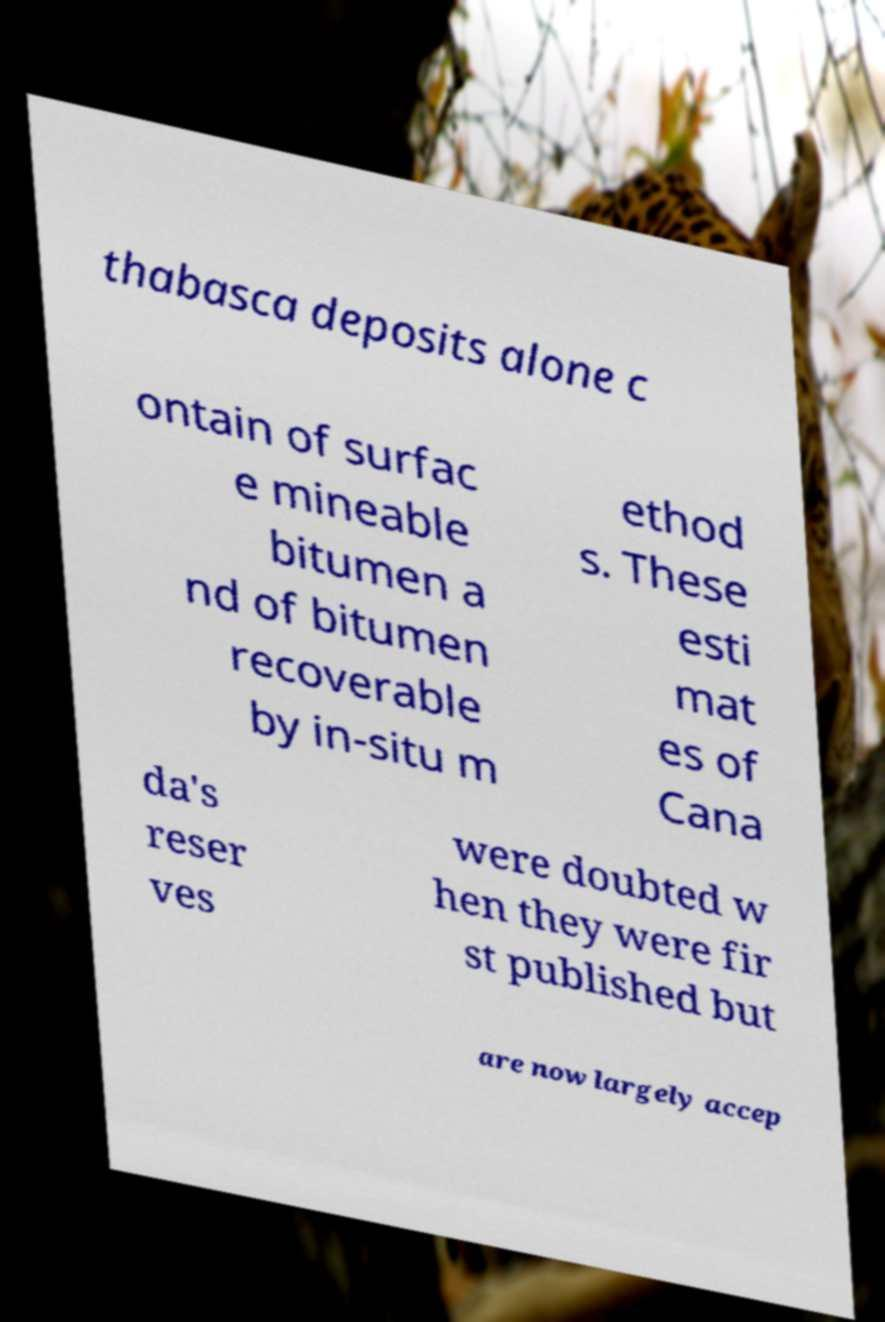Please read and relay the text visible in this image. What does it say? thabasca deposits alone c ontain of surfac e mineable bitumen a nd of bitumen recoverable by in-situ m ethod s. These esti mat es of Cana da's reser ves were doubted w hen they were fir st published but are now largely accep 